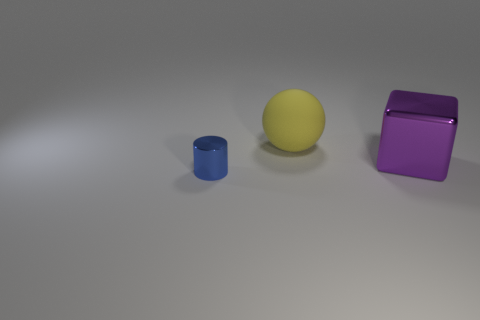There is a shiny thing behind the metallic object to the left of the big cube; how many large balls are in front of it?
Offer a terse response. 0. Does the metal thing that is in front of the big cube have the same shape as the big object that is behind the purple shiny object?
Your answer should be very brief. No. The large object that is behind the metal thing that is to the right of the tiny thing is made of what material?
Provide a succinct answer. Rubber. What color is the other thing that is the same size as the purple object?
Provide a short and direct response. Yellow. The large object that is behind the metallic thing that is to the right of the big object that is to the left of the large purple metallic block is made of what material?
Your answer should be very brief. Rubber. How many things are either things that are on the right side of the blue metallic cylinder or shiny things that are in front of the metal cube?
Your response must be concise. 3. The metal object that is on the left side of the object behind the purple cube is what shape?
Your response must be concise. Cylinder. Are there fewer large yellow matte objects that are behind the large ball than yellow matte balls that are behind the blue metal cylinder?
Ensure brevity in your answer.  Yes. There is a large thing left of the purple block; what is it made of?
Provide a short and direct response. Rubber. How many other objects are there of the same size as the blue metallic cylinder?
Provide a succinct answer. 0. 